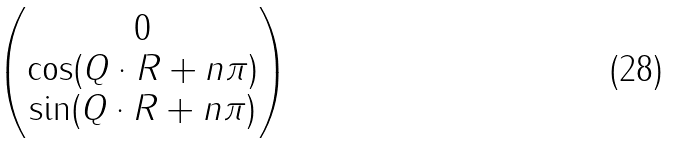<formula> <loc_0><loc_0><loc_500><loc_500>\begin{pmatrix} 0 \\ \cos ( { Q \cdot R } + n \pi ) \\ \sin ( { Q \cdot R } + n \pi ) \end{pmatrix}</formula> 